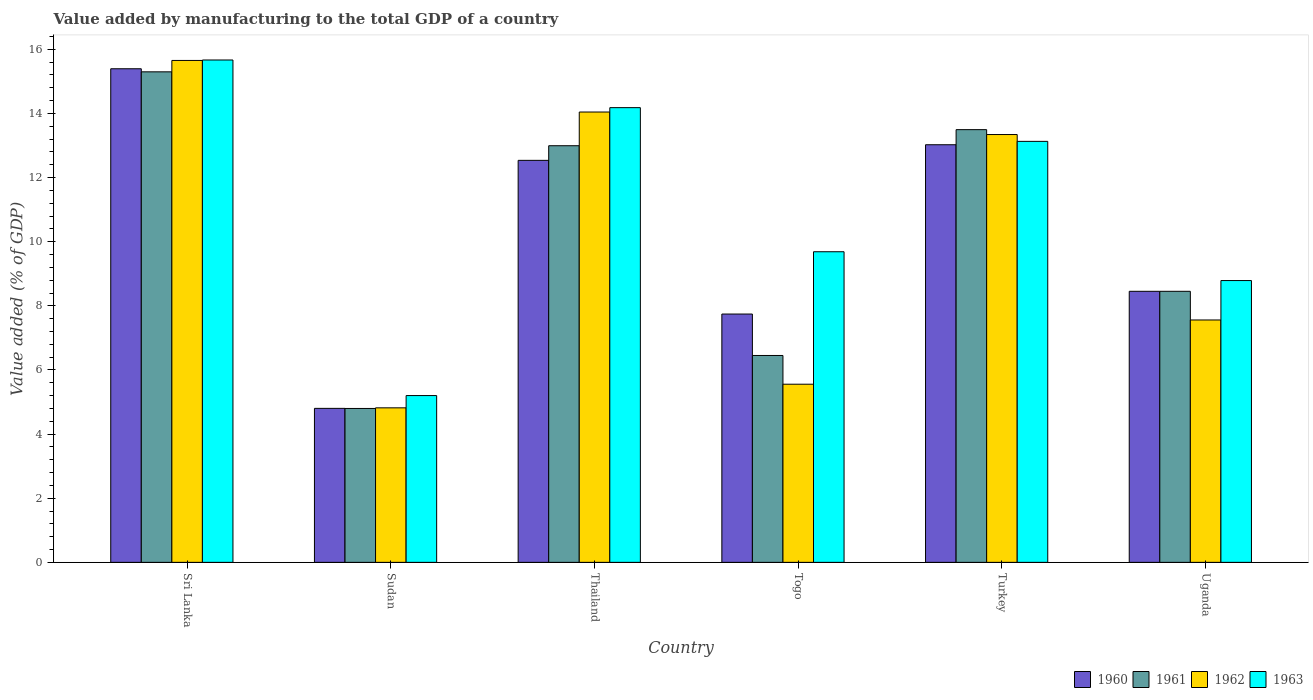How many different coloured bars are there?
Provide a succinct answer. 4. How many groups of bars are there?
Provide a short and direct response. 6. Are the number of bars on each tick of the X-axis equal?
Make the answer very short. Yes. How many bars are there on the 6th tick from the left?
Ensure brevity in your answer.  4. How many bars are there on the 5th tick from the right?
Make the answer very short. 4. What is the label of the 6th group of bars from the left?
Make the answer very short. Uganda. What is the value added by manufacturing to the total GDP in 1961 in Uganda?
Give a very brief answer. 8.45. Across all countries, what is the maximum value added by manufacturing to the total GDP in 1960?
Make the answer very short. 15.39. Across all countries, what is the minimum value added by manufacturing to the total GDP in 1960?
Give a very brief answer. 4.8. In which country was the value added by manufacturing to the total GDP in 1960 maximum?
Keep it short and to the point. Sri Lanka. In which country was the value added by manufacturing to the total GDP in 1963 minimum?
Ensure brevity in your answer.  Sudan. What is the total value added by manufacturing to the total GDP in 1962 in the graph?
Your response must be concise. 60.97. What is the difference between the value added by manufacturing to the total GDP in 1960 in Sri Lanka and that in Togo?
Offer a very short reply. 7.65. What is the difference between the value added by manufacturing to the total GDP in 1961 in Sri Lanka and the value added by manufacturing to the total GDP in 1962 in Thailand?
Keep it short and to the point. 1.25. What is the average value added by manufacturing to the total GDP in 1960 per country?
Give a very brief answer. 10.33. What is the difference between the value added by manufacturing to the total GDP of/in 1960 and value added by manufacturing to the total GDP of/in 1962 in Sri Lanka?
Ensure brevity in your answer.  -0.26. What is the ratio of the value added by manufacturing to the total GDP in 1961 in Sri Lanka to that in Togo?
Offer a very short reply. 2.37. Is the value added by manufacturing to the total GDP in 1962 in Togo less than that in Turkey?
Provide a short and direct response. Yes. Is the difference between the value added by manufacturing to the total GDP in 1960 in Turkey and Uganda greater than the difference between the value added by manufacturing to the total GDP in 1962 in Turkey and Uganda?
Give a very brief answer. No. What is the difference between the highest and the second highest value added by manufacturing to the total GDP in 1960?
Your answer should be very brief. -0.49. What is the difference between the highest and the lowest value added by manufacturing to the total GDP in 1961?
Offer a very short reply. 10.5. Is the sum of the value added by manufacturing to the total GDP in 1960 in Togo and Turkey greater than the maximum value added by manufacturing to the total GDP in 1961 across all countries?
Your answer should be compact. Yes. What does the 1st bar from the right in Turkey represents?
Your answer should be very brief. 1963. Is it the case that in every country, the sum of the value added by manufacturing to the total GDP in 1961 and value added by manufacturing to the total GDP in 1963 is greater than the value added by manufacturing to the total GDP in 1960?
Provide a succinct answer. Yes. How many countries are there in the graph?
Give a very brief answer. 6. Are the values on the major ticks of Y-axis written in scientific E-notation?
Provide a succinct answer. No. Does the graph contain any zero values?
Make the answer very short. No. Does the graph contain grids?
Keep it short and to the point. No. How many legend labels are there?
Make the answer very short. 4. What is the title of the graph?
Ensure brevity in your answer.  Value added by manufacturing to the total GDP of a country. Does "2014" appear as one of the legend labels in the graph?
Give a very brief answer. No. What is the label or title of the Y-axis?
Offer a very short reply. Value added (% of GDP). What is the Value added (% of GDP) in 1960 in Sri Lanka?
Offer a very short reply. 15.39. What is the Value added (% of GDP) of 1961 in Sri Lanka?
Your answer should be compact. 15.3. What is the Value added (% of GDP) in 1962 in Sri Lanka?
Provide a succinct answer. 15.65. What is the Value added (% of GDP) of 1963 in Sri Lanka?
Your response must be concise. 15.67. What is the Value added (% of GDP) of 1960 in Sudan?
Give a very brief answer. 4.8. What is the Value added (% of GDP) in 1961 in Sudan?
Ensure brevity in your answer.  4.8. What is the Value added (% of GDP) of 1962 in Sudan?
Keep it short and to the point. 4.82. What is the Value added (% of GDP) of 1963 in Sudan?
Your answer should be very brief. 5.2. What is the Value added (% of GDP) in 1960 in Thailand?
Provide a succinct answer. 12.54. What is the Value added (% of GDP) in 1961 in Thailand?
Ensure brevity in your answer.  12.99. What is the Value added (% of GDP) in 1962 in Thailand?
Keep it short and to the point. 14.04. What is the Value added (% of GDP) in 1963 in Thailand?
Offer a very short reply. 14.18. What is the Value added (% of GDP) in 1960 in Togo?
Your answer should be compact. 7.74. What is the Value added (% of GDP) of 1961 in Togo?
Give a very brief answer. 6.45. What is the Value added (% of GDP) in 1962 in Togo?
Offer a very short reply. 5.56. What is the Value added (% of GDP) in 1963 in Togo?
Your response must be concise. 9.69. What is the Value added (% of GDP) in 1960 in Turkey?
Offer a terse response. 13.02. What is the Value added (% of GDP) in 1961 in Turkey?
Your answer should be compact. 13.49. What is the Value added (% of GDP) in 1962 in Turkey?
Offer a terse response. 13.34. What is the Value added (% of GDP) in 1963 in Turkey?
Keep it short and to the point. 13.13. What is the Value added (% of GDP) in 1960 in Uganda?
Your answer should be compact. 8.45. What is the Value added (% of GDP) in 1961 in Uganda?
Give a very brief answer. 8.45. What is the Value added (% of GDP) of 1962 in Uganda?
Offer a terse response. 7.56. What is the Value added (% of GDP) of 1963 in Uganda?
Provide a succinct answer. 8.79. Across all countries, what is the maximum Value added (% of GDP) of 1960?
Your answer should be very brief. 15.39. Across all countries, what is the maximum Value added (% of GDP) in 1961?
Offer a terse response. 15.3. Across all countries, what is the maximum Value added (% of GDP) of 1962?
Provide a succinct answer. 15.65. Across all countries, what is the maximum Value added (% of GDP) in 1963?
Ensure brevity in your answer.  15.67. Across all countries, what is the minimum Value added (% of GDP) of 1960?
Offer a very short reply. 4.8. Across all countries, what is the minimum Value added (% of GDP) in 1961?
Give a very brief answer. 4.8. Across all countries, what is the minimum Value added (% of GDP) of 1962?
Offer a very short reply. 4.82. Across all countries, what is the minimum Value added (% of GDP) of 1963?
Your response must be concise. 5.2. What is the total Value added (% of GDP) of 1960 in the graph?
Give a very brief answer. 61.95. What is the total Value added (% of GDP) of 1961 in the graph?
Your answer should be very brief. 61.49. What is the total Value added (% of GDP) in 1962 in the graph?
Your answer should be compact. 60.97. What is the total Value added (% of GDP) of 1963 in the graph?
Make the answer very short. 66.65. What is the difference between the Value added (% of GDP) in 1960 in Sri Lanka and that in Sudan?
Ensure brevity in your answer.  10.59. What is the difference between the Value added (% of GDP) of 1961 in Sri Lanka and that in Sudan?
Your answer should be compact. 10.5. What is the difference between the Value added (% of GDP) of 1962 in Sri Lanka and that in Sudan?
Make the answer very short. 10.83. What is the difference between the Value added (% of GDP) of 1963 in Sri Lanka and that in Sudan?
Make the answer very short. 10.47. What is the difference between the Value added (% of GDP) in 1960 in Sri Lanka and that in Thailand?
Provide a succinct answer. 2.86. What is the difference between the Value added (% of GDP) in 1961 in Sri Lanka and that in Thailand?
Ensure brevity in your answer.  2.3. What is the difference between the Value added (% of GDP) of 1962 in Sri Lanka and that in Thailand?
Give a very brief answer. 1.61. What is the difference between the Value added (% of GDP) of 1963 in Sri Lanka and that in Thailand?
Offer a very short reply. 1.49. What is the difference between the Value added (% of GDP) in 1960 in Sri Lanka and that in Togo?
Provide a short and direct response. 7.65. What is the difference between the Value added (% of GDP) in 1961 in Sri Lanka and that in Togo?
Give a very brief answer. 8.85. What is the difference between the Value added (% of GDP) of 1962 in Sri Lanka and that in Togo?
Keep it short and to the point. 10.1. What is the difference between the Value added (% of GDP) in 1963 in Sri Lanka and that in Togo?
Your answer should be very brief. 5.98. What is the difference between the Value added (% of GDP) in 1960 in Sri Lanka and that in Turkey?
Provide a short and direct response. 2.37. What is the difference between the Value added (% of GDP) of 1961 in Sri Lanka and that in Turkey?
Provide a short and direct response. 1.8. What is the difference between the Value added (% of GDP) of 1962 in Sri Lanka and that in Turkey?
Offer a very short reply. 2.31. What is the difference between the Value added (% of GDP) in 1963 in Sri Lanka and that in Turkey?
Your response must be concise. 2.54. What is the difference between the Value added (% of GDP) of 1960 in Sri Lanka and that in Uganda?
Provide a short and direct response. 6.94. What is the difference between the Value added (% of GDP) in 1961 in Sri Lanka and that in Uganda?
Your response must be concise. 6.84. What is the difference between the Value added (% of GDP) of 1962 in Sri Lanka and that in Uganda?
Keep it short and to the point. 8.09. What is the difference between the Value added (% of GDP) of 1963 in Sri Lanka and that in Uganda?
Make the answer very short. 6.88. What is the difference between the Value added (% of GDP) of 1960 in Sudan and that in Thailand?
Give a very brief answer. -7.73. What is the difference between the Value added (% of GDP) in 1961 in Sudan and that in Thailand?
Offer a very short reply. -8.19. What is the difference between the Value added (% of GDP) of 1962 in Sudan and that in Thailand?
Your answer should be very brief. -9.23. What is the difference between the Value added (% of GDP) in 1963 in Sudan and that in Thailand?
Ensure brevity in your answer.  -8.98. What is the difference between the Value added (% of GDP) of 1960 in Sudan and that in Togo?
Your answer should be very brief. -2.94. What is the difference between the Value added (% of GDP) of 1961 in Sudan and that in Togo?
Ensure brevity in your answer.  -1.65. What is the difference between the Value added (% of GDP) of 1962 in Sudan and that in Togo?
Your answer should be compact. -0.74. What is the difference between the Value added (% of GDP) of 1963 in Sudan and that in Togo?
Provide a succinct answer. -4.49. What is the difference between the Value added (% of GDP) of 1960 in Sudan and that in Turkey?
Ensure brevity in your answer.  -8.22. What is the difference between the Value added (% of GDP) of 1961 in Sudan and that in Turkey?
Your response must be concise. -8.69. What is the difference between the Value added (% of GDP) in 1962 in Sudan and that in Turkey?
Give a very brief answer. -8.52. What is the difference between the Value added (% of GDP) of 1963 in Sudan and that in Turkey?
Your answer should be compact. -7.93. What is the difference between the Value added (% of GDP) of 1960 in Sudan and that in Uganda?
Make the answer very short. -3.65. What is the difference between the Value added (% of GDP) of 1961 in Sudan and that in Uganda?
Provide a short and direct response. -3.65. What is the difference between the Value added (% of GDP) in 1962 in Sudan and that in Uganda?
Offer a very short reply. -2.74. What is the difference between the Value added (% of GDP) of 1963 in Sudan and that in Uganda?
Keep it short and to the point. -3.59. What is the difference between the Value added (% of GDP) of 1960 in Thailand and that in Togo?
Offer a very short reply. 4.79. What is the difference between the Value added (% of GDP) in 1961 in Thailand and that in Togo?
Make the answer very short. 6.54. What is the difference between the Value added (% of GDP) of 1962 in Thailand and that in Togo?
Offer a very short reply. 8.49. What is the difference between the Value added (% of GDP) in 1963 in Thailand and that in Togo?
Offer a very short reply. 4.49. What is the difference between the Value added (% of GDP) in 1960 in Thailand and that in Turkey?
Ensure brevity in your answer.  -0.49. What is the difference between the Value added (% of GDP) in 1961 in Thailand and that in Turkey?
Provide a succinct answer. -0.5. What is the difference between the Value added (% of GDP) in 1962 in Thailand and that in Turkey?
Your answer should be very brief. 0.7. What is the difference between the Value added (% of GDP) in 1963 in Thailand and that in Turkey?
Ensure brevity in your answer.  1.05. What is the difference between the Value added (% of GDP) of 1960 in Thailand and that in Uganda?
Provide a short and direct response. 4.08. What is the difference between the Value added (% of GDP) in 1961 in Thailand and that in Uganda?
Keep it short and to the point. 4.54. What is the difference between the Value added (% of GDP) of 1962 in Thailand and that in Uganda?
Provide a succinct answer. 6.49. What is the difference between the Value added (% of GDP) of 1963 in Thailand and that in Uganda?
Offer a very short reply. 5.39. What is the difference between the Value added (% of GDP) of 1960 in Togo and that in Turkey?
Offer a terse response. -5.28. What is the difference between the Value added (% of GDP) in 1961 in Togo and that in Turkey?
Provide a succinct answer. -7.04. What is the difference between the Value added (% of GDP) in 1962 in Togo and that in Turkey?
Provide a succinct answer. -7.79. What is the difference between the Value added (% of GDP) in 1963 in Togo and that in Turkey?
Ensure brevity in your answer.  -3.44. What is the difference between the Value added (% of GDP) of 1960 in Togo and that in Uganda?
Make the answer very short. -0.71. What is the difference between the Value added (% of GDP) of 1961 in Togo and that in Uganda?
Keep it short and to the point. -2. What is the difference between the Value added (% of GDP) of 1962 in Togo and that in Uganda?
Your answer should be compact. -2. What is the difference between the Value added (% of GDP) in 1963 in Togo and that in Uganda?
Keep it short and to the point. 0.9. What is the difference between the Value added (% of GDP) in 1960 in Turkey and that in Uganda?
Your response must be concise. 4.57. What is the difference between the Value added (% of GDP) in 1961 in Turkey and that in Uganda?
Offer a terse response. 5.04. What is the difference between the Value added (% of GDP) of 1962 in Turkey and that in Uganda?
Your response must be concise. 5.78. What is the difference between the Value added (% of GDP) of 1963 in Turkey and that in Uganda?
Provide a succinct answer. 4.34. What is the difference between the Value added (% of GDP) in 1960 in Sri Lanka and the Value added (% of GDP) in 1961 in Sudan?
Your response must be concise. 10.59. What is the difference between the Value added (% of GDP) of 1960 in Sri Lanka and the Value added (% of GDP) of 1962 in Sudan?
Provide a short and direct response. 10.57. What is the difference between the Value added (% of GDP) in 1960 in Sri Lanka and the Value added (% of GDP) in 1963 in Sudan?
Give a very brief answer. 10.19. What is the difference between the Value added (% of GDP) in 1961 in Sri Lanka and the Value added (% of GDP) in 1962 in Sudan?
Provide a short and direct response. 10.48. What is the difference between the Value added (% of GDP) in 1961 in Sri Lanka and the Value added (% of GDP) in 1963 in Sudan?
Provide a succinct answer. 10.1. What is the difference between the Value added (% of GDP) in 1962 in Sri Lanka and the Value added (% of GDP) in 1963 in Sudan?
Keep it short and to the point. 10.45. What is the difference between the Value added (% of GDP) of 1960 in Sri Lanka and the Value added (% of GDP) of 1961 in Thailand?
Offer a very short reply. 2.4. What is the difference between the Value added (% of GDP) in 1960 in Sri Lanka and the Value added (% of GDP) in 1962 in Thailand?
Your answer should be very brief. 1.35. What is the difference between the Value added (% of GDP) in 1960 in Sri Lanka and the Value added (% of GDP) in 1963 in Thailand?
Your response must be concise. 1.21. What is the difference between the Value added (% of GDP) of 1961 in Sri Lanka and the Value added (% of GDP) of 1962 in Thailand?
Your response must be concise. 1.25. What is the difference between the Value added (% of GDP) in 1961 in Sri Lanka and the Value added (% of GDP) in 1963 in Thailand?
Your answer should be very brief. 1.12. What is the difference between the Value added (% of GDP) in 1962 in Sri Lanka and the Value added (% of GDP) in 1963 in Thailand?
Provide a succinct answer. 1.47. What is the difference between the Value added (% of GDP) in 1960 in Sri Lanka and the Value added (% of GDP) in 1961 in Togo?
Your response must be concise. 8.94. What is the difference between the Value added (% of GDP) of 1960 in Sri Lanka and the Value added (% of GDP) of 1962 in Togo?
Provide a short and direct response. 9.84. What is the difference between the Value added (% of GDP) in 1960 in Sri Lanka and the Value added (% of GDP) in 1963 in Togo?
Your response must be concise. 5.71. What is the difference between the Value added (% of GDP) in 1961 in Sri Lanka and the Value added (% of GDP) in 1962 in Togo?
Keep it short and to the point. 9.74. What is the difference between the Value added (% of GDP) in 1961 in Sri Lanka and the Value added (% of GDP) in 1963 in Togo?
Your response must be concise. 5.61. What is the difference between the Value added (% of GDP) of 1962 in Sri Lanka and the Value added (% of GDP) of 1963 in Togo?
Make the answer very short. 5.97. What is the difference between the Value added (% of GDP) in 1960 in Sri Lanka and the Value added (% of GDP) in 1961 in Turkey?
Offer a terse response. 1.9. What is the difference between the Value added (% of GDP) of 1960 in Sri Lanka and the Value added (% of GDP) of 1962 in Turkey?
Ensure brevity in your answer.  2.05. What is the difference between the Value added (% of GDP) in 1960 in Sri Lanka and the Value added (% of GDP) in 1963 in Turkey?
Offer a very short reply. 2.26. What is the difference between the Value added (% of GDP) of 1961 in Sri Lanka and the Value added (% of GDP) of 1962 in Turkey?
Provide a succinct answer. 1.96. What is the difference between the Value added (% of GDP) in 1961 in Sri Lanka and the Value added (% of GDP) in 1963 in Turkey?
Ensure brevity in your answer.  2.17. What is the difference between the Value added (% of GDP) of 1962 in Sri Lanka and the Value added (% of GDP) of 1963 in Turkey?
Your answer should be compact. 2.52. What is the difference between the Value added (% of GDP) in 1960 in Sri Lanka and the Value added (% of GDP) in 1961 in Uganda?
Your answer should be compact. 6.94. What is the difference between the Value added (% of GDP) in 1960 in Sri Lanka and the Value added (% of GDP) in 1962 in Uganda?
Your response must be concise. 7.83. What is the difference between the Value added (% of GDP) of 1960 in Sri Lanka and the Value added (% of GDP) of 1963 in Uganda?
Offer a terse response. 6.6. What is the difference between the Value added (% of GDP) in 1961 in Sri Lanka and the Value added (% of GDP) in 1962 in Uganda?
Provide a succinct answer. 7.74. What is the difference between the Value added (% of GDP) of 1961 in Sri Lanka and the Value added (% of GDP) of 1963 in Uganda?
Your response must be concise. 6.51. What is the difference between the Value added (% of GDP) in 1962 in Sri Lanka and the Value added (% of GDP) in 1963 in Uganda?
Make the answer very short. 6.86. What is the difference between the Value added (% of GDP) in 1960 in Sudan and the Value added (% of GDP) in 1961 in Thailand?
Provide a succinct answer. -8.19. What is the difference between the Value added (% of GDP) in 1960 in Sudan and the Value added (% of GDP) in 1962 in Thailand?
Make the answer very short. -9.24. What is the difference between the Value added (% of GDP) of 1960 in Sudan and the Value added (% of GDP) of 1963 in Thailand?
Provide a short and direct response. -9.38. What is the difference between the Value added (% of GDP) of 1961 in Sudan and the Value added (% of GDP) of 1962 in Thailand?
Offer a very short reply. -9.24. What is the difference between the Value added (% of GDP) of 1961 in Sudan and the Value added (% of GDP) of 1963 in Thailand?
Offer a very short reply. -9.38. What is the difference between the Value added (% of GDP) of 1962 in Sudan and the Value added (% of GDP) of 1963 in Thailand?
Your answer should be very brief. -9.36. What is the difference between the Value added (% of GDP) of 1960 in Sudan and the Value added (% of GDP) of 1961 in Togo?
Provide a short and direct response. -1.65. What is the difference between the Value added (% of GDP) of 1960 in Sudan and the Value added (% of GDP) of 1962 in Togo?
Give a very brief answer. -0.75. What is the difference between the Value added (% of GDP) in 1960 in Sudan and the Value added (% of GDP) in 1963 in Togo?
Keep it short and to the point. -4.88. What is the difference between the Value added (% of GDP) of 1961 in Sudan and the Value added (% of GDP) of 1962 in Togo?
Provide a succinct answer. -0.76. What is the difference between the Value added (% of GDP) in 1961 in Sudan and the Value added (% of GDP) in 1963 in Togo?
Your answer should be very brief. -4.89. What is the difference between the Value added (% of GDP) of 1962 in Sudan and the Value added (% of GDP) of 1963 in Togo?
Your answer should be very brief. -4.87. What is the difference between the Value added (% of GDP) of 1960 in Sudan and the Value added (% of GDP) of 1961 in Turkey?
Offer a very short reply. -8.69. What is the difference between the Value added (% of GDP) of 1960 in Sudan and the Value added (% of GDP) of 1962 in Turkey?
Your answer should be very brief. -8.54. What is the difference between the Value added (% of GDP) of 1960 in Sudan and the Value added (% of GDP) of 1963 in Turkey?
Keep it short and to the point. -8.33. What is the difference between the Value added (% of GDP) in 1961 in Sudan and the Value added (% of GDP) in 1962 in Turkey?
Keep it short and to the point. -8.54. What is the difference between the Value added (% of GDP) of 1961 in Sudan and the Value added (% of GDP) of 1963 in Turkey?
Offer a very short reply. -8.33. What is the difference between the Value added (% of GDP) in 1962 in Sudan and the Value added (% of GDP) in 1963 in Turkey?
Your answer should be compact. -8.31. What is the difference between the Value added (% of GDP) of 1960 in Sudan and the Value added (% of GDP) of 1961 in Uganda?
Offer a terse response. -3.65. What is the difference between the Value added (% of GDP) of 1960 in Sudan and the Value added (% of GDP) of 1962 in Uganda?
Offer a very short reply. -2.76. What is the difference between the Value added (% of GDP) in 1960 in Sudan and the Value added (% of GDP) in 1963 in Uganda?
Give a very brief answer. -3.99. What is the difference between the Value added (% of GDP) in 1961 in Sudan and the Value added (% of GDP) in 1962 in Uganda?
Provide a succinct answer. -2.76. What is the difference between the Value added (% of GDP) in 1961 in Sudan and the Value added (% of GDP) in 1963 in Uganda?
Provide a succinct answer. -3.99. What is the difference between the Value added (% of GDP) in 1962 in Sudan and the Value added (% of GDP) in 1963 in Uganda?
Offer a very short reply. -3.97. What is the difference between the Value added (% of GDP) of 1960 in Thailand and the Value added (% of GDP) of 1961 in Togo?
Your response must be concise. 6.09. What is the difference between the Value added (% of GDP) of 1960 in Thailand and the Value added (% of GDP) of 1962 in Togo?
Your answer should be very brief. 6.98. What is the difference between the Value added (% of GDP) of 1960 in Thailand and the Value added (% of GDP) of 1963 in Togo?
Your answer should be very brief. 2.85. What is the difference between the Value added (% of GDP) in 1961 in Thailand and the Value added (% of GDP) in 1962 in Togo?
Provide a short and direct response. 7.44. What is the difference between the Value added (% of GDP) in 1961 in Thailand and the Value added (% of GDP) in 1963 in Togo?
Keep it short and to the point. 3.31. What is the difference between the Value added (% of GDP) in 1962 in Thailand and the Value added (% of GDP) in 1963 in Togo?
Keep it short and to the point. 4.36. What is the difference between the Value added (% of GDP) in 1960 in Thailand and the Value added (% of GDP) in 1961 in Turkey?
Provide a short and direct response. -0.96. What is the difference between the Value added (% of GDP) of 1960 in Thailand and the Value added (% of GDP) of 1962 in Turkey?
Your answer should be compact. -0.81. What is the difference between the Value added (% of GDP) in 1960 in Thailand and the Value added (% of GDP) in 1963 in Turkey?
Your answer should be compact. -0.59. What is the difference between the Value added (% of GDP) of 1961 in Thailand and the Value added (% of GDP) of 1962 in Turkey?
Offer a terse response. -0.35. What is the difference between the Value added (% of GDP) in 1961 in Thailand and the Value added (% of GDP) in 1963 in Turkey?
Keep it short and to the point. -0.14. What is the difference between the Value added (% of GDP) in 1962 in Thailand and the Value added (% of GDP) in 1963 in Turkey?
Keep it short and to the point. 0.92. What is the difference between the Value added (% of GDP) in 1960 in Thailand and the Value added (% of GDP) in 1961 in Uganda?
Your answer should be very brief. 4.08. What is the difference between the Value added (% of GDP) in 1960 in Thailand and the Value added (% of GDP) in 1962 in Uganda?
Your answer should be very brief. 4.98. What is the difference between the Value added (% of GDP) of 1960 in Thailand and the Value added (% of GDP) of 1963 in Uganda?
Keep it short and to the point. 3.75. What is the difference between the Value added (% of GDP) of 1961 in Thailand and the Value added (% of GDP) of 1962 in Uganda?
Keep it short and to the point. 5.43. What is the difference between the Value added (% of GDP) in 1961 in Thailand and the Value added (% of GDP) in 1963 in Uganda?
Your response must be concise. 4.2. What is the difference between the Value added (% of GDP) of 1962 in Thailand and the Value added (% of GDP) of 1963 in Uganda?
Make the answer very short. 5.26. What is the difference between the Value added (% of GDP) in 1960 in Togo and the Value added (% of GDP) in 1961 in Turkey?
Your answer should be compact. -5.75. What is the difference between the Value added (% of GDP) in 1960 in Togo and the Value added (% of GDP) in 1962 in Turkey?
Your response must be concise. -5.6. What is the difference between the Value added (% of GDP) in 1960 in Togo and the Value added (% of GDP) in 1963 in Turkey?
Offer a very short reply. -5.38. What is the difference between the Value added (% of GDP) in 1961 in Togo and the Value added (% of GDP) in 1962 in Turkey?
Provide a succinct answer. -6.89. What is the difference between the Value added (% of GDP) of 1961 in Togo and the Value added (% of GDP) of 1963 in Turkey?
Offer a terse response. -6.68. What is the difference between the Value added (% of GDP) in 1962 in Togo and the Value added (% of GDP) in 1963 in Turkey?
Keep it short and to the point. -7.57. What is the difference between the Value added (% of GDP) in 1960 in Togo and the Value added (% of GDP) in 1961 in Uganda?
Your answer should be very brief. -0.71. What is the difference between the Value added (% of GDP) in 1960 in Togo and the Value added (% of GDP) in 1962 in Uganda?
Make the answer very short. 0.19. What is the difference between the Value added (% of GDP) of 1960 in Togo and the Value added (% of GDP) of 1963 in Uganda?
Provide a succinct answer. -1.04. What is the difference between the Value added (% of GDP) in 1961 in Togo and the Value added (% of GDP) in 1962 in Uganda?
Provide a short and direct response. -1.11. What is the difference between the Value added (% of GDP) of 1961 in Togo and the Value added (% of GDP) of 1963 in Uganda?
Keep it short and to the point. -2.34. What is the difference between the Value added (% of GDP) in 1962 in Togo and the Value added (% of GDP) in 1963 in Uganda?
Offer a very short reply. -3.23. What is the difference between the Value added (% of GDP) of 1960 in Turkey and the Value added (% of GDP) of 1961 in Uganda?
Your answer should be compact. 4.57. What is the difference between the Value added (% of GDP) in 1960 in Turkey and the Value added (% of GDP) in 1962 in Uganda?
Offer a terse response. 5.47. What is the difference between the Value added (% of GDP) of 1960 in Turkey and the Value added (% of GDP) of 1963 in Uganda?
Provide a succinct answer. 4.24. What is the difference between the Value added (% of GDP) in 1961 in Turkey and the Value added (% of GDP) in 1962 in Uganda?
Provide a succinct answer. 5.94. What is the difference between the Value added (% of GDP) in 1961 in Turkey and the Value added (% of GDP) in 1963 in Uganda?
Your answer should be very brief. 4.71. What is the difference between the Value added (% of GDP) in 1962 in Turkey and the Value added (% of GDP) in 1963 in Uganda?
Keep it short and to the point. 4.55. What is the average Value added (% of GDP) in 1960 per country?
Your response must be concise. 10.33. What is the average Value added (% of GDP) in 1961 per country?
Your response must be concise. 10.25. What is the average Value added (% of GDP) in 1962 per country?
Provide a succinct answer. 10.16. What is the average Value added (% of GDP) in 1963 per country?
Give a very brief answer. 11.11. What is the difference between the Value added (% of GDP) in 1960 and Value added (% of GDP) in 1961 in Sri Lanka?
Give a very brief answer. 0.1. What is the difference between the Value added (% of GDP) of 1960 and Value added (% of GDP) of 1962 in Sri Lanka?
Keep it short and to the point. -0.26. What is the difference between the Value added (% of GDP) in 1960 and Value added (% of GDP) in 1963 in Sri Lanka?
Your answer should be compact. -0.27. What is the difference between the Value added (% of GDP) of 1961 and Value added (% of GDP) of 1962 in Sri Lanka?
Provide a succinct answer. -0.35. What is the difference between the Value added (% of GDP) of 1961 and Value added (% of GDP) of 1963 in Sri Lanka?
Offer a terse response. -0.37. What is the difference between the Value added (% of GDP) in 1962 and Value added (% of GDP) in 1963 in Sri Lanka?
Your answer should be compact. -0.01. What is the difference between the Value added (% of GDP) in 1960 and Value added (% of GDP) in 1961 in Sudan?
Your answer should be very brief. 0. What is the difference between the Value added (% of GDP) of 1960 and Value added (% of GDP) of 1962 in Sudan?
Your answer should be very brief. -0.02. What is the difference between the Value added (% of GDP) in 1960 and Value added (% of GDP) in 1963 in Sudan?
Provide a short and direct response. -0.4. What is the difference between the Value added (% of GDP) of 1961 and Value added (% of GDP) of 1962 in Sudan?
Provide a succinct answer. -0.02. What is the difference between the Value added (% of GDP) of 1961 and Value added (% of GDP) of 1963 in Sudan?
Offer a terse response. -0.4. What is the difference between the Value added (% of GDP) in 1962 and Value added (% of GDP) in 1963 in Sudan?
Keep it short and to the point. -0.38. What is the difference between the Value added (% of GDP) of 1960 and Value added (% of GDP) of 1961 in Thailand?
Your response must be concise. -0.46. What is the difference between the Value added (% of GDP) in 1960 and Value added (% of GDP) in 1962 in Thailand?
Provide a short and direct response. -1.51. What is the difference between the Value added (% of GDP) in 1960 and Value added (% of GDP) in 1963 in Thailand?
Provide a succinct answer. -1.64. What is the difference between the Value added (% of GDP) in 1961 and Value added (% of GDP) in 1962 in Thailand?
Offer a terse response. -1.05. What is the difference between the Value added (% of GDP) in 1961 and Value added (% of GDP) in 1963 in Thailand?
Provide a short and direct response. -1.19. What is the difference between the Value added (% of GDP) in 1962 and Value added (% of GDP) in 1963 in Thailand?
Your answer should be compact. -0.14. What is the difference between the Value added (% of GDP) in 1960 and Value added (% of GDP) in 1961 in Togo?
Your answer should be compact. 1.29. What is the difference between the Value added (% of GDP) of 1960 and Value added (% of GDP) of 1962 in Togo?
Provide a short and direct response. 2.19. What is the difference between the Value added (% of GDP) in 1960 and Value added (% of GDP) in 1963 in Togo?
Keep it short and to the point. -1.94. What is the difference between the Value added (% of GDP) of 1961 and Value added (% of GDP) of 1962 in Togo?
Your response must be concise. 0.9. What is the difference between the Value added (% of GDP) of 1961 and Value added (% of GDP) of 1963 in Togo?
Your response must be concise. -3.23. What is the difference between the Value added (% of GDP) of 1962 and Value added (% of GDP) of 1963 in Togo?
Make the answer very short. -4.13. What is the difference between the Value added (% of GDP) in 1960 and Value added (% of GDP) in 1961 in Turkey?
Your answer should be very brief. -0.47. What is the difference between the Value added (% of GDP) of 1960 and Value added (% of GDP) of 1962 in Turkey?
Keep it short and to the point. -0.32. What is the difference between the Value added (% of GDP) in 1960 and Value added (% of GDP) in 1963 in Turkey?
Your answer should be very brief. -0.11. What is the difference between the Value added (% of GDP) in 1961 and Value added (% of GDP) in 1962 in Turkey?
Offer a very short reply. 0.15. What is the difference between the Value added (% of GDP) in 1961 and Value added (% of GDP) in 1963 in Turkey?
Your response must be concise. 0.37. What is the difference between the Value added (% of GDP) of 1962 and Value added (% of GDP) of 1963 in Turkey?
Provide a succinct answer. 0.21. What is the difference between the Value added (% of GDP) in 1960 and Value added (% of GDP) in 1961 in Uganda?
Keep it short and to the point. -0. What is the difference between the Value added (% of GDP) of 1960 and Value added (% of GDP) of 1962 in Uganda?
Provide a succinct answer. 0.89. What is the difference between the Value added (% of GDP) of 1960 and Value added (% of GDP) of 1963 in Uganda?
Provide a succinct answer. -0.34. What is the difference between the Value added (% of GDP) of 1961 and Value added (% of GDP) of 1962 in Uganda?
Your response must be concise. 0.89. What is the difference between the Value added (% of GDP) of 1961 and Value added (% of GDP) of 1963 in Uganda?
Provide a short and direct response. -0.34. What is the difference between the Value added (% of GDP) of 1962 and Value added (% of GDP) of 1963 in Uganda?
Ensure brevity in your answer.  -1.23. What is the ratio of the Value added (% of GDP) of 1960 in Sri Lanka to that in Sudan?
Ensure brevity in your answer.  3.21. What is the ratio of the Value added (% of GDP) of 1961 in Sri Lanka to that in Sudan?
Give a very brief answer. 3.19. What is the ratio of the Value added (% of GDP) in 1962 in Sri Lanka to that in Sudan?
Ensure brevity in your answer.  3.25. What is the ratio of the Value added (% of GDP) of 1963 in Sri Lanka to that in Sudan?
Offer a terse response. 3.01. What is the ratio of the Value added (% of GDP) in 1960 in Sri Lanka to that in Thailand?
Keep it short and to the point. 1.23. What is the ratio of the Value added (% of GDP) of 1961 in Sri Lanka to that in Thailand?
Your answer should be very brief. 1.18. What is the ratio of the Value added (% of GDP) in 1962 in Sri Lanka to that in Thailand?
Provide a short and direct response. 1.11. What is the ratio of the Value added (% of GDP) of 1963 in Sri Lanka to that in Thailand?
Ensure brevity in your answer.  1.1. What is the ratio of the Value added (% of GDP) of 1960 in Sri Lanka to that in Togo?
Keep it short and to the point. 1.99. What is the ratio of the Value added (% of GDP) in 1961 in Sri Lanka to that in Togo?
Provide a succinct answer. 2.37. What is the ratio of the Value added (% of GDP) in 1962 in Sri Lanka to that in Togo?
Provide a short and direct response. 2.82. What is the ratio of the Value added (% of GDP) in 1963 in Sri Lanka to that in Togo?
Your answer should be compact. 1.62. What is the ratio of the Value added (% of GDP) of 1960 in Sri Lanka to that in Turkey?
Provide a succinct answer. 1.18. What is the ratio of the Value added (% of GDP) of 1961 in Sri Lanka to that in Turkey?
Your response must be concise. 1.13. What is the ratio of the Value added (% of GDP) of 1962 in Sri Lanka to that in Turkey?
Give a very brief answer. 1.17. What is the ratio of the Value added (% of GDP) of 1963 in Sri Lanka to that in Turkey?
Offer a terse response. 1.19. What is the ratio of the Value added (% of GDP) in 1960 in Sri Lanka to that in Uganda?
Your response must be concise. 1.82. What is the ratio of the Value added (% of GDP) in 1961 in Sri Lanka to that in Uganda?
Offer a very short reply. 1.81. What is the ratio of the Value added (% of GDP) in 1962 in Sri Lanka to that in Uganda?
Make the answer very short. 2.07. What is the ratio of the Value added (% of GDP) of 1963 in Sri Lanka to that in Uganda?
Your answer should be very brief. 1.78. What is the ratio of the Value added (% of GDP) of 1960 in Sudan to that in Thailand?
Offer a very short reply. 0.38. What is the ratio of the Value added (% of GDP) in 1961 in Sudan to that in Thailand?
Ensure brevity in your answer.  0.37. What is the ratio of the Value added (% of GDP) of 1962 in Sudan to that in Thailand?
Provide a succinct answer. 0.34. What is the ratio of the Value added (% of GDP) in 1963 in Sudan to that in Thailand?
Make the answer very short. 0.37. What is the ratio of the Value added (% of GDP) in 1960 in Sudan to that in Togo?
Provide a short and direct response. 0.62. What is the ratio of the Value added (% of GDP) in 1961 in Sudan to that in Togo?
Offer a very short reply. 0.74. What is the ratio of the Value added (% of GDP) of 1962 in Sudan to that in Togo?
Your answer should be very brief. 0.87. What is the ratio of the Value added (% of GDP) in 1963 in Sudan to that in Togo?
Provide a short and direct response. 0.54. What is the ratio of the Value added (% of GDP) in 1960 in Sudan to that in Turkey?
Provide a short and direct response. 0.37. What is the ratio of the Value added (% of GDP) of 1961 in Sudan to that in Turkey?
Your response must be concise. 0.36. What is the ratio of the Value added (% of GDP) of 1962 in Sudan to that in Turkey?
Provide a short and direct response. 0.36. What is the ratio of the Value added (% of GDP) in 1963 in Sudan to that in Turkey?
Offer a very short reply. 0.4. What is the ratio of the Value added (% of GDP) of 1960 in Sudan to that in Uganda?
Provide a succinct answer. 0.57. What is the ratio of the Value added (% of GDP) in 1961 in Sudan to that in Uganda?
Offer a very short reply. 0.57. What is the ratio of the Value added (% of GDP) of 1962 in Sudan to that in Uganda?
Provide a succinct answer. 0.64. What is the ratio of the Value added (% of GDP) of 1963 in Sudan to that in Uganda?
Provide a succinct answer. 0.59. What is the ratio of the Value added (% of GDP) of 1960 in Thailand to that in Togo?
Offer a very short reply. 1.62. What is the ratio of the Value added (% of GDP) of 1961 in Thailand to that in Togo?
Provide a short and direct response. 2.01. What is the ratio of the Value added (% of GDP) in 1962 in Thailand to that in Togo?
Provide a succinct answer. 2.53. What is the ratio of the Value added (% of GDP) in 1963 in Thailand to that in Togo?
Give a very brief answer. 1.46. What is the ratio of the Value added (% of GDP) in 1960 in Thailand to that in Turkey?
Your response must be concise. 0.96. What is the ratio of the Value added (% of GDP) in 1961 in Thailand to that in Turkey?
Offer a very short reply. 0.96. What is the ratio of the Value added (% of GDP) in 1962 in Thailand to that in Turkey?
Your response must be concise. 1.05. What is the ratio of the Value added (% of GDP) of 1963 in Thailand to that in Turkey?
Offer a very short reply. 1.08. What is the ratio of the Value added (% of GDP) in 1960 in Thailand to that in Uganda?
Offer a terse response. 1.48. What is the ratio of the Value added (% of GDP) of 1961 in Thailand to that in Uganda?
Your response must be concise. 1.54. What is the ratio of the Value added (% of GDP) in 1962 in Thailand to that in Uganda?
Make the answer very short. 1.86. What is the ratio of the Value added (% of GDP) in 1963 in Thailand to that in Uganda?
Provide a short and direct response. 1.61. What is the ratio of the Value added (% of GDP) in 1960 in Togo to that in Turkey?
Provide a succinct answer. 0.59. What is the ratio of the Value added (% of GDP) of 1961 in Togo to that in Turkey?
Make the answer very short. 0.48. What is the ratio of the Value added (% of GDP) in 1962 in Togo to that in Turkey?
Provide a short and direct response. 0.42. What is the ratio of the Value added (% of GDP) in 1963 in Togo to that in Turkey?
Make the answer very short. 0.74. What is the ratio of the Value added (% of GDP) in 1960 in Togo to that in Uganda?
Give a very brief answer. 0.92. What is the ratio of the Value added (% of GDP) of 1961 in Togo to that in Uganda?
Make the answer very short. 0.76. What is the ratio of the Value added (% of GDP) of 1962 in Togo to that in Uganda?
Ensure brevity in your answer.  0.73. What is the ratio of the Value added (% of GDP) in 1963 in Togo to that in Uganda?
Provide a succinct answer. 1.1. What is the ratio of the Value added (% of GDP) in 1960 in Turkey to that in Uganda?
Your response must be concise. 1.54. What is the ratio of the Value added (% of GDP) of 1961 in Turkey to that in Uganda?
Your answer should be very brief. 1.6. What is the ratio of the Value added (% of GDP) in 1962 in Turkey to that in Uganda?
Offer a very short reply. 1.77. What is the ratio of the Value added (% of GDP) in 1963 in Turkey to that in Uganda?
Give a very brief answer. 1.49. What is the difference between the highest and the second highest Value added (% of GDP) of 1960?
Your answer should be very brief. 2.37. What is the difference between the highest and the second highest Value added (% of GDP) of 1961?
Offer a terse response. 1.8. What is the difference between the highest and the second highest Value added (% of GDP) in 1962?
Your response must be concise. 1.61. What is the difference between the highest and the second highest Value added (% of GDP) of 1963?
Ensure brevity in your answer.  1.49. What is the difference between the highest and the lowest Value added (% of GDP) in 1960?
Offer a very short reply. 10.59. What is the difference between the highest and the lowest Value added (% of GDP) of 1961?
Ensure brevity in your answer.  10.5. What is the difference between the highest and the lowest Value added (% of GDP) of 1962?
Provide a short and direct response. 10.83. What is the difference between the highest and the lowest Value added (% of GDP) of 1963?
Provide a succinct answer. 10.47. 